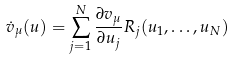<formula> <loc_0><loc_0><loc_500><loc_500>\dot { v } _ { \mu } ( u ) = \sum _ { j = 1 } ^ { N } \frac { \partial v _ { \mu } } { \partial u _ { j } } R _ { j } ( u _ { 1 } , \dots , u _ { N } )</formula> 